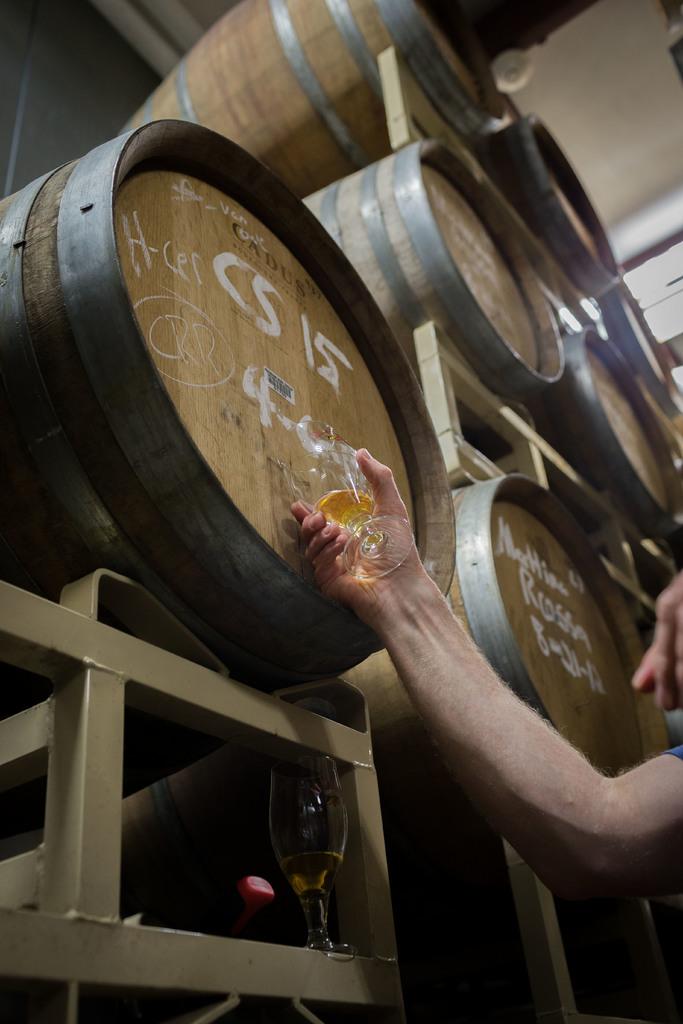What is the brand of the wooden barrel?
Your response must be concise. Cadus. 